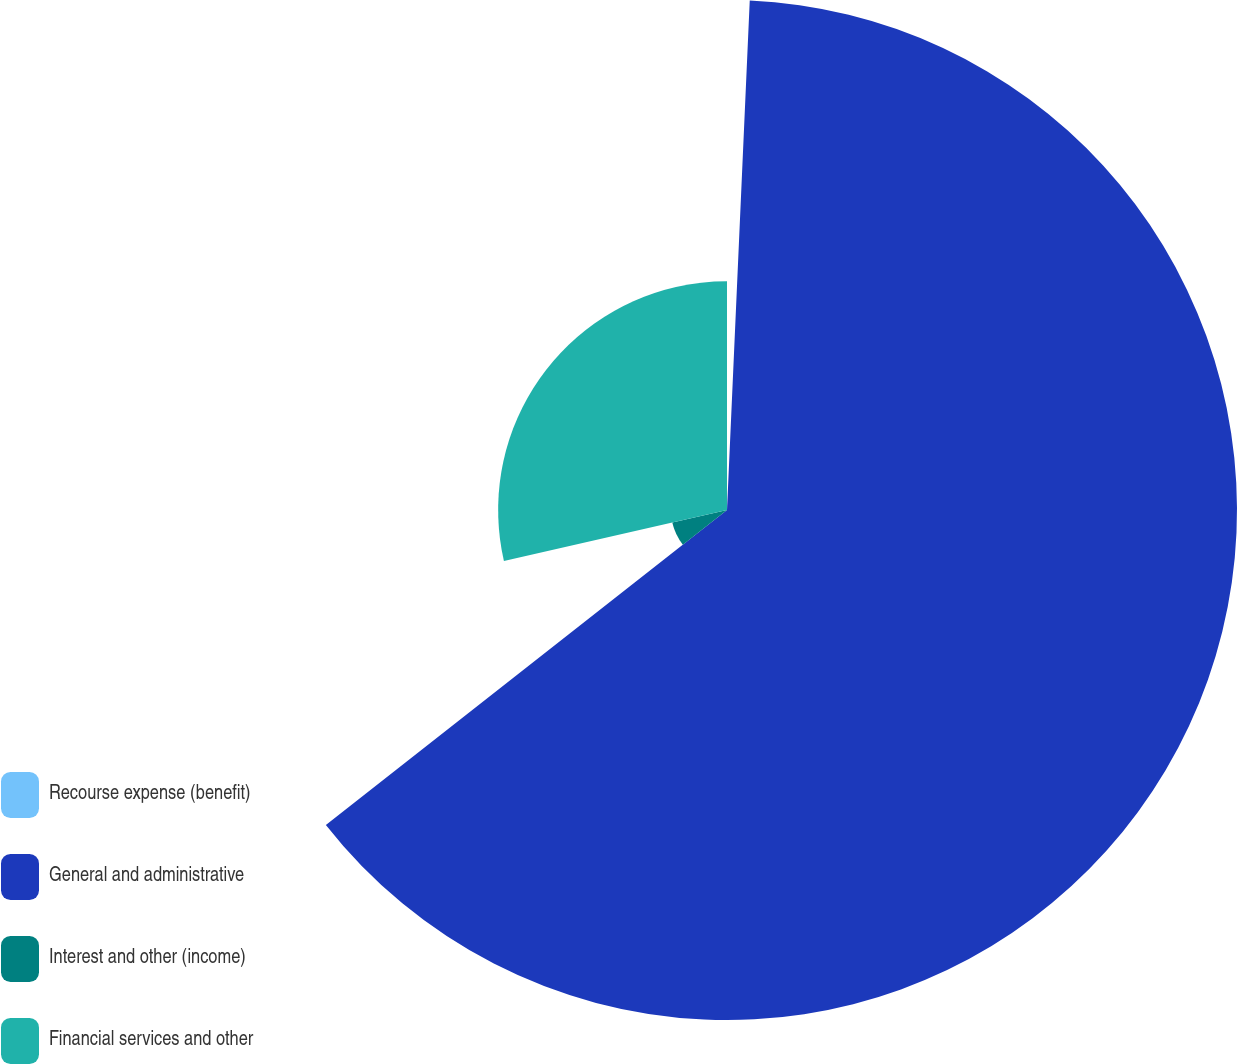<chart> <loc_0><loc_0><loc_500><loc_500><pie_chart><fcel>Recourse expense (benefit)<fcel>General and administrative<fcel>Interest and other (income)<fcel>Financial services and other<nl><fcel>0.71%<fcel>63.69%<fcel>7.01%<fcel>28.58%<nl></chart> 